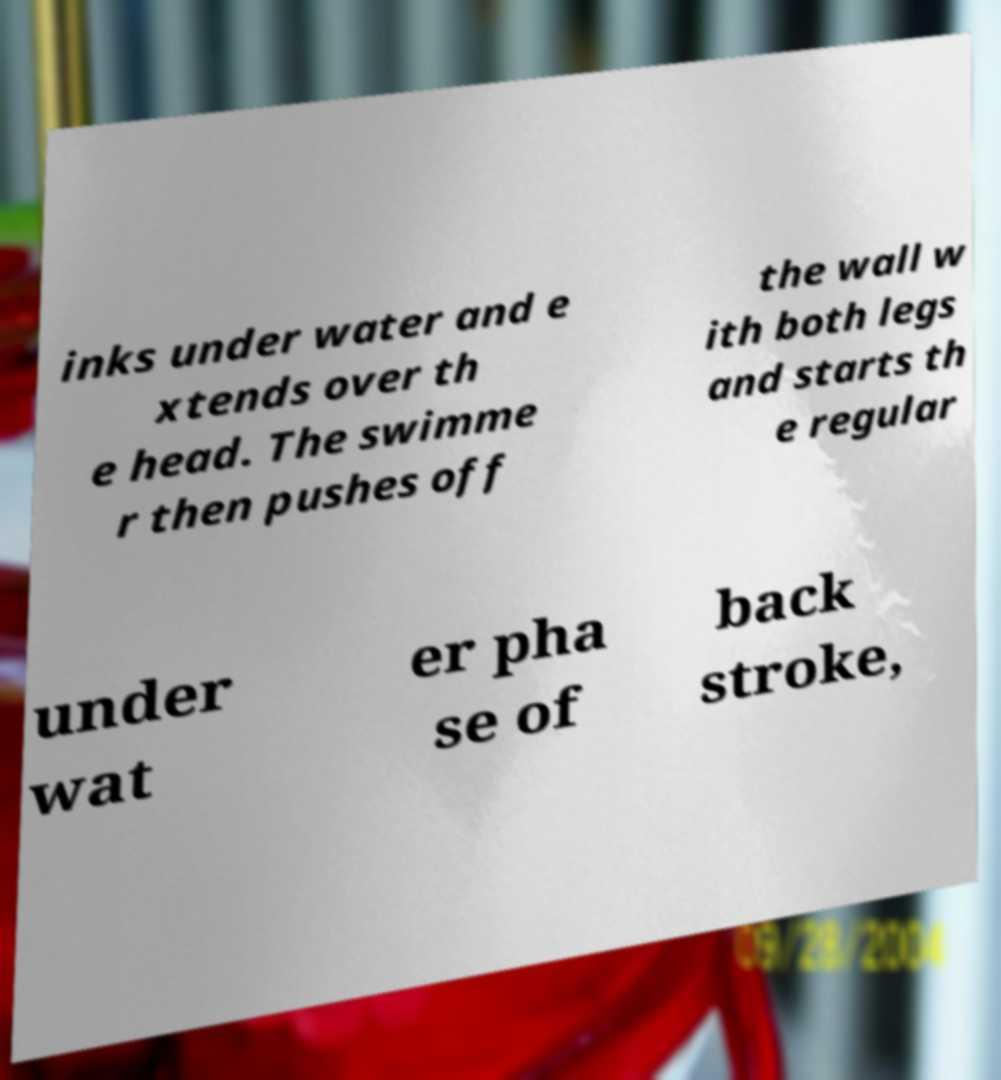What messages or text are displayed in this image? I need them in a readable, typed format. inks under water and e xtends over th e head. The swimme r then pushes off the wall w ith both legs and starts th e regular under wat er pha se of back stroke, 